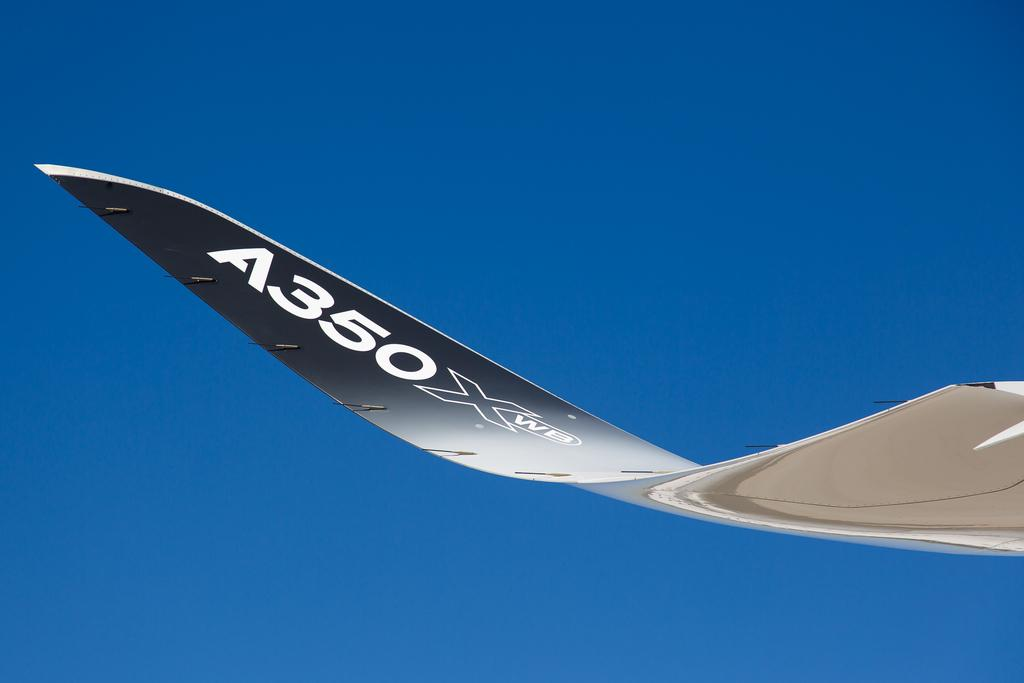<image>
Render a clear and concise summary of the photo. a wing of an air craft with the letters and numbers A350x on it. 